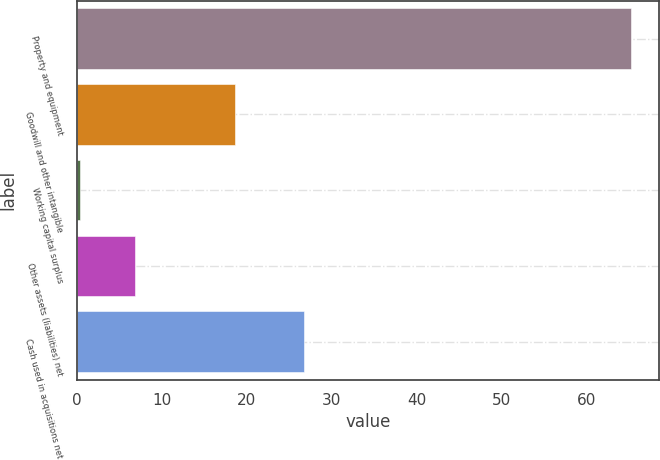Convert chart. <chart><loc_0><loc_0><loc_500><loc_500><bar_chart><fcel>Property and equipment<fcel>Goodwill and other intangible<fcel>Working capital surplus<fcel>Other assets (liabilities) net<fcel>Cash used in acquisitions net<nl><fcel>65.3<fcel>18.6<fcel>0.3<fcel>6.8<fcel>26.7<nl></chart> 